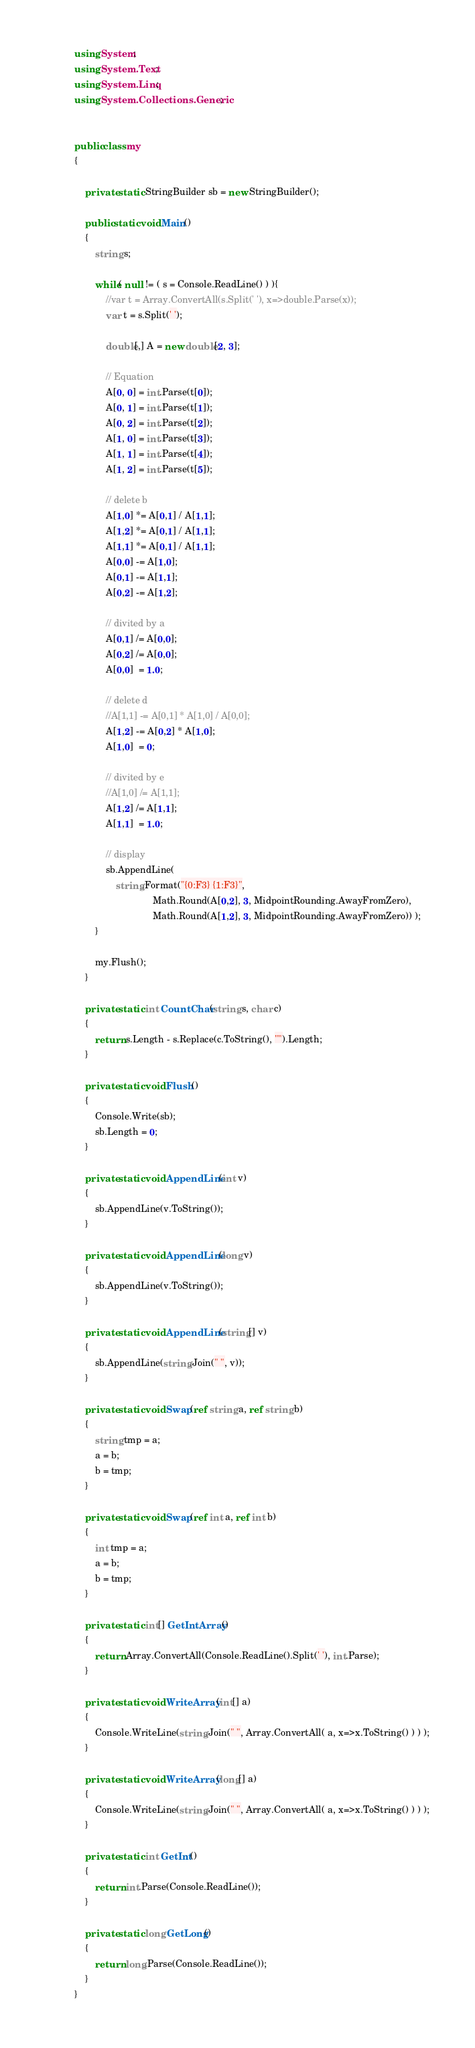Convert code to text. <code><loc_0><loc_0><loc_500><loc_500><_C#_>using System;
using System.Text;
using System.Linq;
using System.Collections.Generic;


public class my
{
	
	private static StringBuilder sb = new StringBuilder();
	
	public static void Main()
	{
		string s;

		while( null != ( s = Console.ReadLine() ) ){
			//var t = Array.ConvertAll(s.Split(' '), x=>double.Parse(x));
			var t = s.Split(' ');
			
			double[,] A = new double[2, 3];
			
			// Equation
			A[0, 0] = int.Parse(t[0]);
			A[0, 1] = int.Parse(t[1]);
			A[0, 2] = int.Parse(t[2]);
			A[1, 0] = int.Parse(t[3]);
			A[1, 1] = int.Parse(t[4]);
			A[1, 2] = int.Parse(t[5]);
			
			// delete b
			A[1,0] *= A[0,1] / A[1,1];
			A[1,2] *= A[0,1] / A[1,1];
			A[1,1] *= A[0,1] / A[1,1];
			A[0,0] -= A[1,0];
			A[0,1] -= A[1,1];
			A[0,2] -= A[1,2];
			
			// divited by a
			A[0,1] /= A[0,0];
			A[0,2] /= A[0,0];
			A[0,0]  = 1.0;
			
			// delete d
			//A[1,1] -= A[0,1] * A[1,0] / A[0,0];
			A[1,2] -= A[0,2] * A[1,0];
			A[1,0]  = 0;
			
			// divited by e
			//A[1,0] /= A[1,1];
			A[1,2] /= A[1,1];
			A[1,1]  = 1.0;
			
			// display
			sb.AppendLine(
				string.Format("{0:F3} {1:F3}", 
							  Math.Round(A[0,2], 3, MidpointRounding.AwayFromZero), 
							  Math.Round(A[1,2], 3, MidpointRounding.AwayFromZero)) );
		}
		
		my.Flush();
	}
	
	private static int CountChar(string s, char c)
	{
		return s.Length - s.Replace(c.ToString(), "").Length;
	}
	
	private static void Flush()
	{
		Console.Write(sb);
		sb.Length = 0;
	}
	
	private static void AppendLine(int v)
	{
		sb.AppendLine(v.ToString());
	}
	
	private static void AppendLine(long v)
	{
		sb.AppendLine(v.ToString());
	}
	
	private static void AppendLine(string[] v)
	{
		sb.AppendLine(string.Join(" ", v));
	}

	private static void Swap(ref string a, ref string b) 
	{
		string tmp = a;
		a = b;
		b = tmp;
	}
	
	private static void Swap(ref int a, ref int b) 
	{
		int tmp = a;
		a = b;
		b = tmp;
	}
	
	private static int[] GetIntArray()
	{
		return Array.ConvertAll(Console.ReadLine().Split(' '), int.Parse);
	}
	
	private static void WriteArray(int[] a)
	{
		Console.WriteLine(string.Join(" ", Array.ConvertAll( a, x=>x.ToString() ) ) );
	}
	
	private static void WriteArray(long[] a)
	{
		Console.WriteLine(string.Join(" ", Array.ConvertAll( a, x=>x.ToString() ) ) );
	}
	
	private static int GetInt()
	{
		return int.Parse(Console.ReadLine());
	}
	
	private static long GetLong()
	{
		return long.Parse(Console.ReadLine());
	}
}</code> 